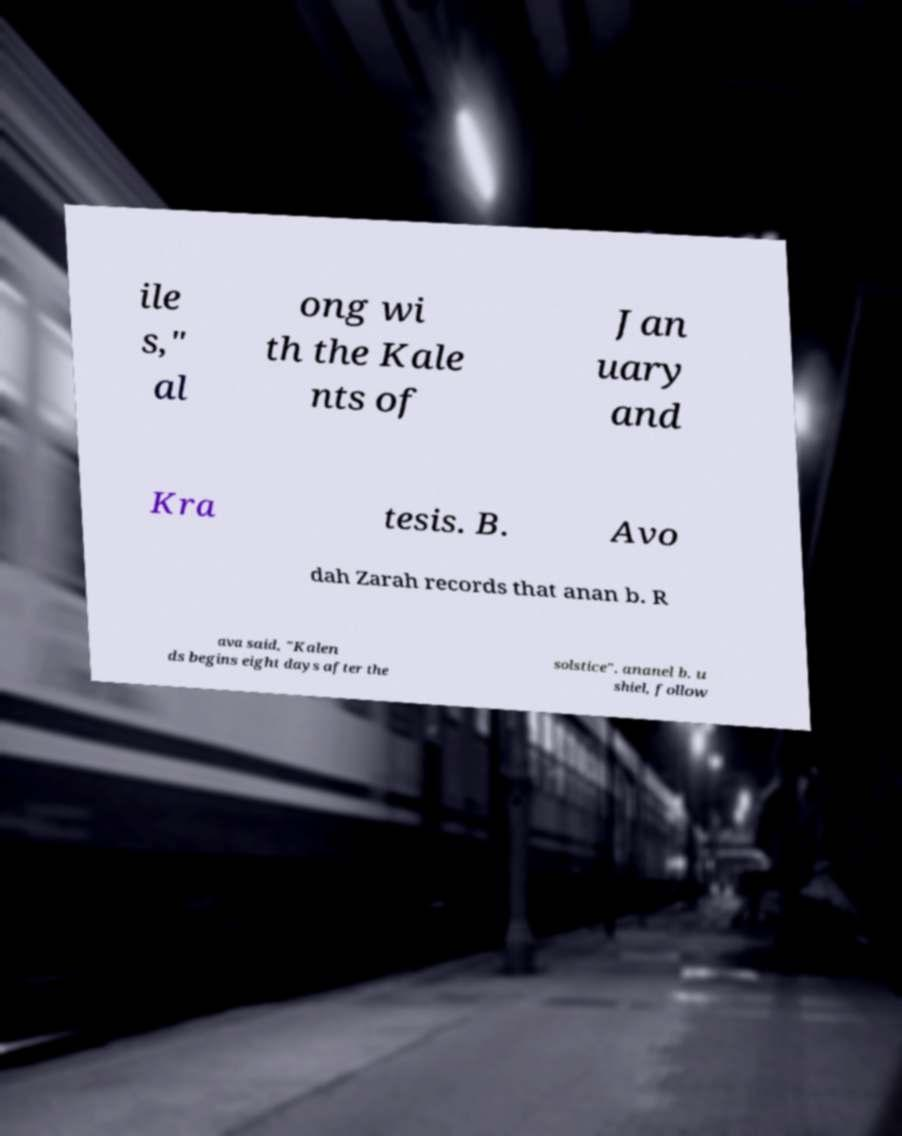There's text embedded in this image that I need extracted. Can you transcribe it verbatim? ile s," al ong wi th the Kale nts of Jan uary and Kra tesis. B. Avo dah Zarah records that anan b. R ava said, "Kalen ds begins eight days after the solstice". ananel b. u shiel, follow 